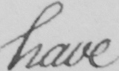Please provide the text content of this handwritten line. have 